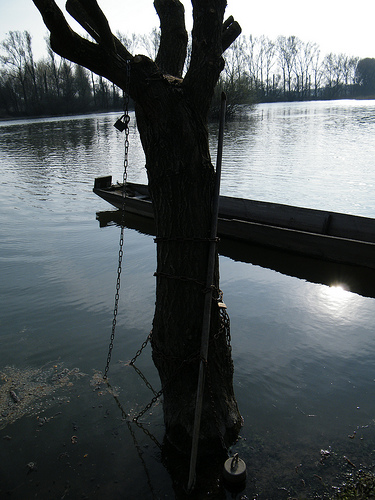<image>
Is there a chain on the tree? Yes. Looking at the image, I can see the chain is positioned on top of the tree, with the tree providing support. Is the tree in front of the boat? Yes. The tree is positioned in front of the boat, appearing closer to the camera viewpoint. 